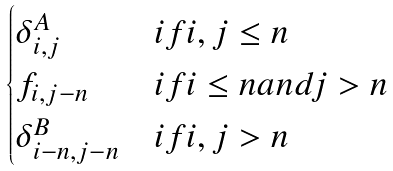Convert formula to latex. <formula><loc_0><loc_0><loc_500><loc_500>\begin{cases} \delta ^ { A } _ { i , j } & i f i , j \leq n \\ f _ { i , j - n } & i f i \leq n a n d j > n \\ \delta ^ { B } _ { i - n , j - n } & i f i , j > n \end{cases}</formula> 